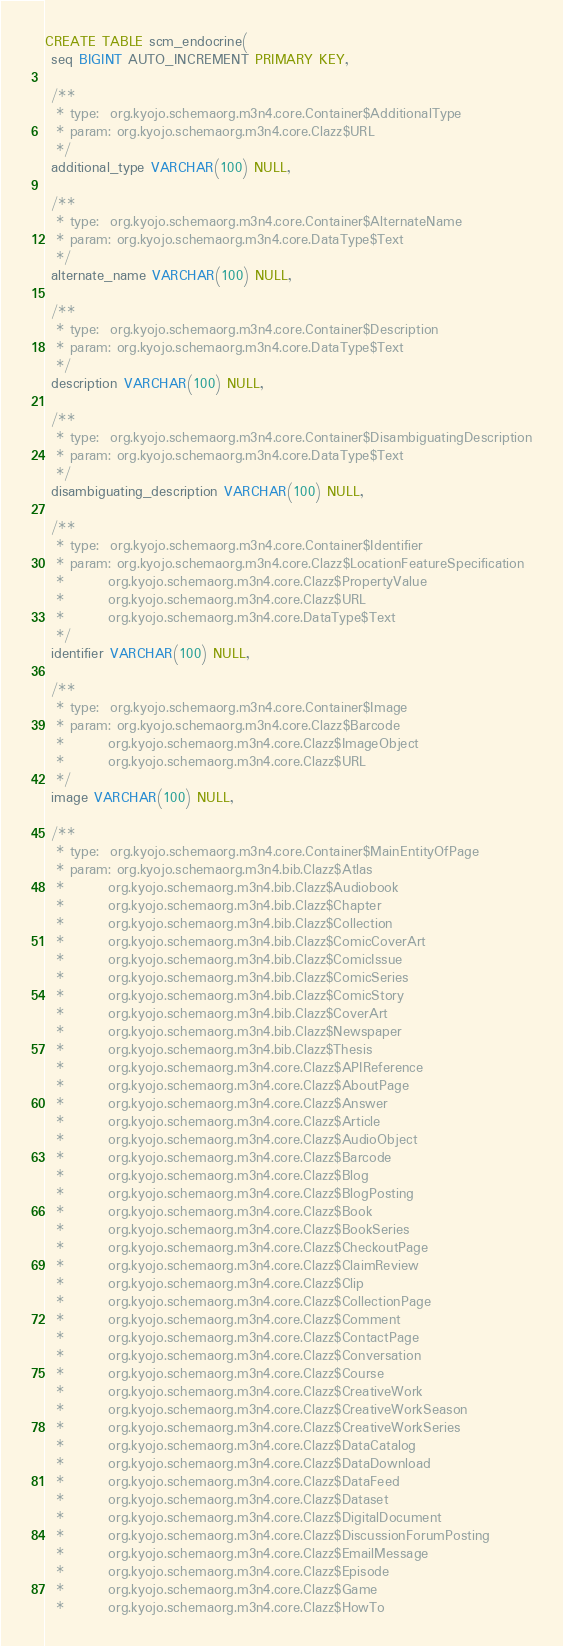<code> <loc_0><loc_0><loc_500><loc_500><_SQL_>CREATE TABLE scm_endocrine(
 seq BIGINT AUTO_INCREMENT PRIMARY KEY,

 /**
  * type:  org.kyojo.schemaorg.m3n4.core.Container$AdditionalType
  * param: org.kyojo.schemaorg.m3n4.core.Clazz$URL
  */
 additional_type VARCHAR(100) NULL,

 /**
  * type:  org.kyojo.schemaorg.m3n4.core.Container$AlternateName
  * param: org.kyojo.schemaorg.m3n4.core.DataType$Text
  */
 alternate_name VARCHAR(100) NULL,

 /**
  * type:  org.kyojo.schemaorg.m3n4.core.Container$Description
  * param: org.kyojo.schemaorg.m3n4.core.DataType$Text
  */
 description VARCHAR(100) NULL,

 /**
  * type:  org.kyojo.schemaorg.m3n4.core.Container$DisambiguatingDescription
  * param: org.kyojo.schemaorg.m3n4.core.DataType$Text
  */
 disambiguating_description VARCHAR(100) NULL,

 /**
  * type:  org.kyojo.schemaorg.m3n4.core.Container$Identifier
  * param: org.kyojo.schemaorg.m3n4.core.Clazz$LocationFeatureSpecification
  *        org.kyojo.schemaorg.m3n4.core.Clazz$PropertyValue
  *        org.kyojo.schemaorg.m3n4.core.Clazz$URL
  *        org.kyojo.schemaorg.m3n4.core.DataType$Text
  */
 identifier VARCHAR(100) NULL,

 /**
  * type:  org.kyojo.schemaorg.m3n4.core.Container$Image
  * param: org.kyojo.schemaorg.m3n4.core.Clazz$Barcode
  *        org.kyojo.schemaorg.m3n4.core.Clazz$ImageObject
  *        org.kyojo.schemaorg.m3n4.core.Clazz$URL
  */
 image VARCHAR(100) NULL,

 /**
  * type:  org.kyojo.schemaorg.m3n4.core.Container$MainEntityOfPage
  * param: org.kyojo.schemaorg.m3n4.bib.Clazz$Atlas
  *        org.kyojo.schemaorg.m3n4.bib.Clazz$Audiobook
  *        org.kyojo.schemaorg.m3n4.bib.Clazz$Chapter
  *        org.kyojo.schemaorg.m3n4.bib.Clazz$Collection
  *        org.kyojo.schemaorg.m3n4.bib.Clazz$ComicCoverArt
  *        org.kyojo.schemaorg.m3n4.bib.Clazz$ComicIssue
  *        org.kyojo.schemaorg.m3n4.bib.Clazz$ComicSeries
  *        org.kyojo.schemaorg.m3n4.bib.Clazz$ComicStory
  *        org.kyojo.schemaorg.m3n4.bib.Clazz$CoverArt
  *        org.kyojo.schemaorg.m3n4.bib.Clazz$Newspaper
  *        org.kyojo.schemaorg.m3n4.bib.Clazz$Thesis
  *        org.kyojo.schemaorg.m3n4.core.Clazz$APIReference
  *        org.kyojo.schemaorg.m3n4.core.Clazz$AboutPage
  *        org.kyojo.schemaorg.m3n4.core.Clazz$Answer
  *        org.kyojo.schemaorg.m3n4.core.Clazz$Article
  *        org.kyojo.schemaorg.m3n4.core.Clazz$AudioObject
  *        org.kyojo.schemaorg.m3n4.core.Clazz$Barcode
  *        org.kyojo.schemaorg.m3n4.core.Clazz$Blog
  *        org.kyojo.schemaorg.m3n4.core.Clazz$BlogPosting
  *        org.kyojo.schemaorg.m3n4.core.Clazz$Book
  *        org.kyojo.schemaorg.m3n4.core.Clazz$BookSeries
  *        org.kyojo.schemaorg.m3n4.core.Clazz$CheckoutPage
  *        org.kyojo.schemaorg.m3n4.core.Clazz$ClaimReview
  *        org.kyojo.schemaorg.m3n4.core.Clazz$Clip
  *        org.kyojo.schemaorg.m3n4.core.Clazz$CollectionPage
  *        org.kyojo.schemaorg.m3n4.core.Clazz$Comment
  *        org.kyojo.schemaorg.m3n4.core.Clazz$ContactPage
  *        org.kyojo.schemaorg.m3n4.core.Clazz$Conversation
  *        org.kyojo.schemaorg.m3n4.core.Clazz$Course
  *        org.kyojo.schemaorg.m3n4.core.Clazz$CreativeWork
  *        org.kyojo.schemaorg.m3n4.core.Clazz$CreativeWorkSeason
  *        org.kyojo.schemaorg.m3n4.core.Clazz$CreativeWorkSeries
  *        org.kyojo.schemaorg.m3n4.core.Clazz$DataCatalog
  *        org.kyojo.schemaorg.m3n4.core.Clazz$DataDownload
  *        org.kyojo.schemaorg.m3n4.core.Clazz$DataFeed
  *        org.kyojo.schemaorg.m3n4.core.Clazz$Dataset
  *        org.kyojo.schemaorg.m3n4.core.Clazz$DigitalDocument
  *        org.kyojo.schemaorg.m3n4.core.Clazz$DiscussionForumPosting
  *        org.kyojo.schemaorg.m3n4.core.Clazz$EmailMessage
  *        org.kyojo.schemaorg.m3n4.core.Clazz$Episode
  *        org.kyojo.schemaorg.m3n4.core.Clazz$Game
  *        org.kyojo.schemaorg.m3n4.core.Clazz$HowTo</code> 